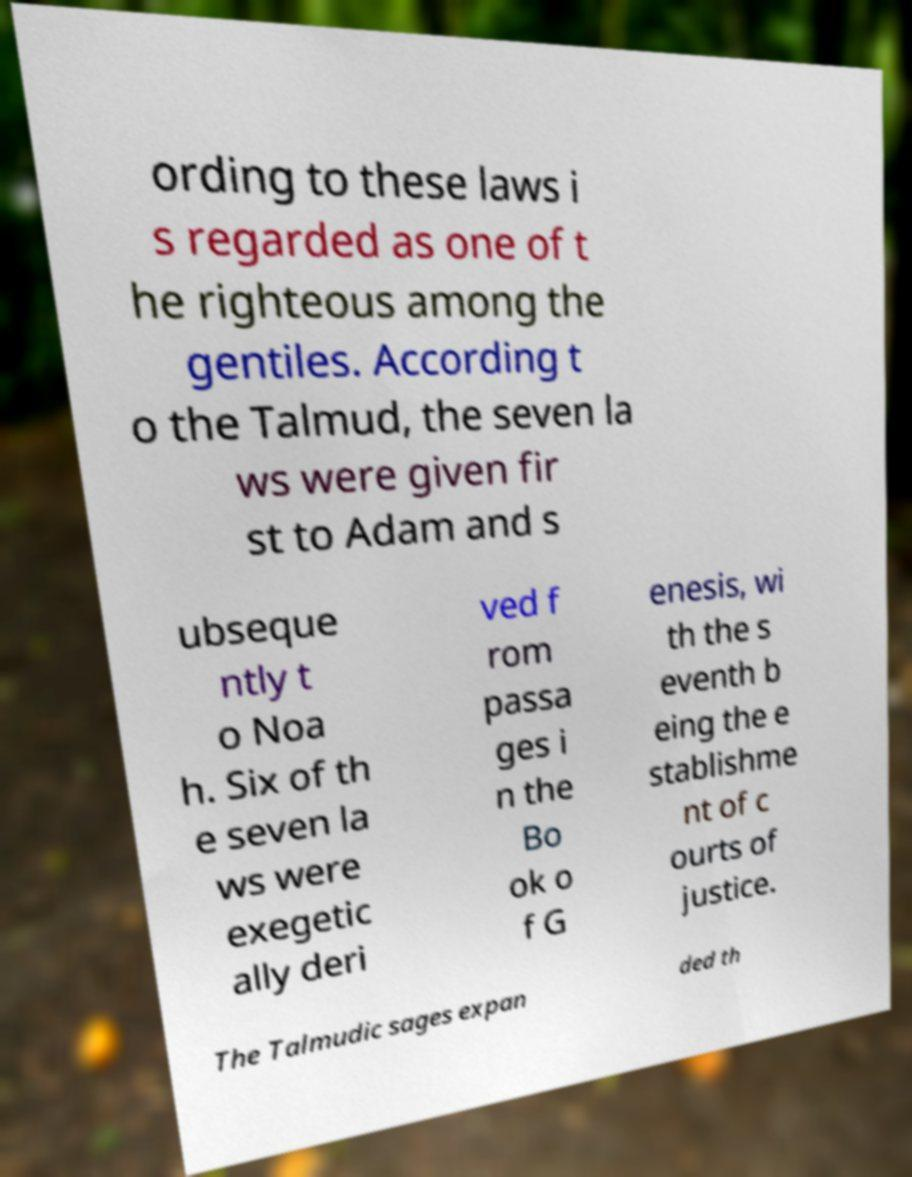Please identify and transcribe the text found in this image. ording to these laws i s regarded as one of t he righteous among the gentiles. According t o the Talmud, the seven la ws were given fir st to Adam and s ubseque ntly t o Noa h. Six of th e seven la ws were exegetic ally deri ved f rom passa ges i n the Bo ok o f G enesis, wi th the s eventh b eing the e stablishme nt of c ourts of justice. The Talmudic sages expan ded th 